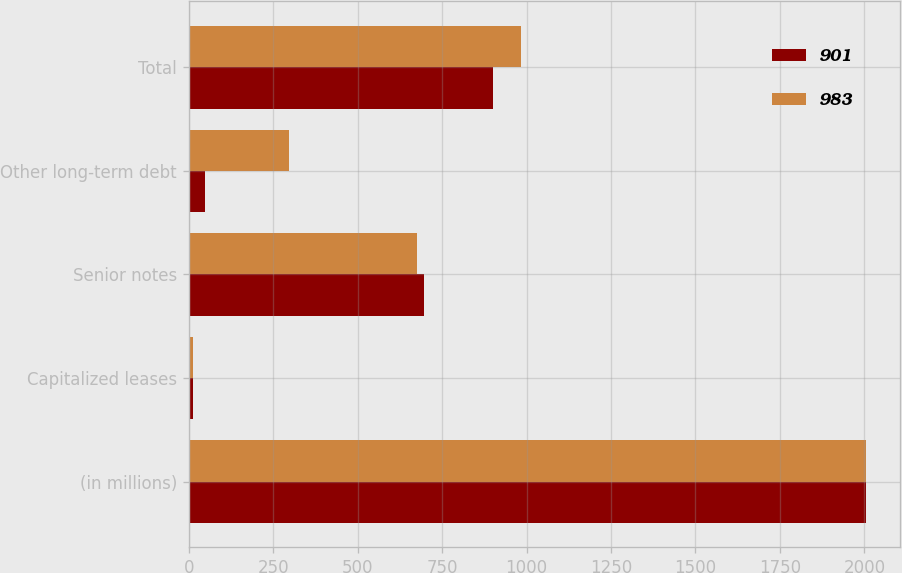Convert chart. <chart><loc_0><loc_0><loc_500><loc_500><stacked_bar_chart><ecel><fcel>(in millions)<fcel>Capitalized leases<fcel>Senior notes<fcel>Other long-term debt<fcel>Total<nl><fcel>901<fcel>2005<fcel>13<fcel>697<fcel>47<fcel>901<nl><fcel>983<fcel>2004<fcel>12<fcel>675<fcel>296<fcel>983<nl></chart> 